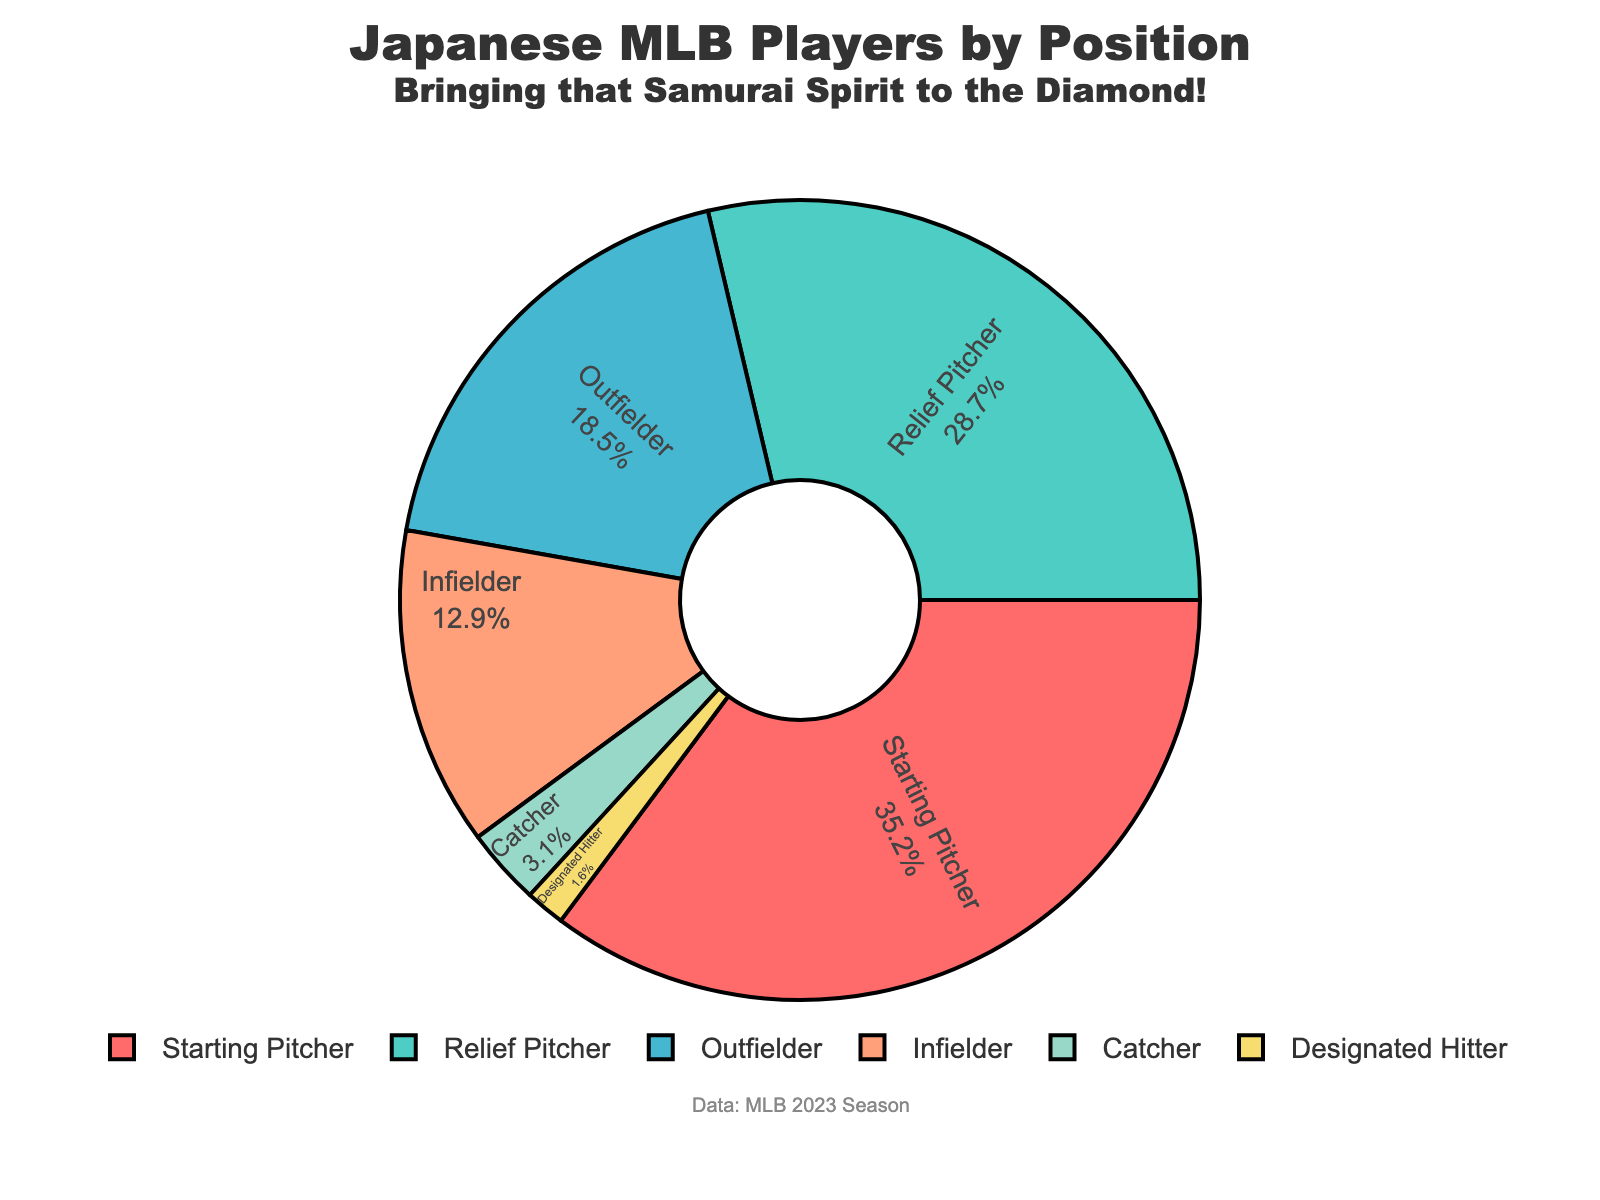Which position has the highest percentage of Japanese-born players in MLB? By observing the chart, we see that Starting Pitchers take up the largest segment.
Answer: Starting Pitcher What is the difference in percentage between Starting Pitchers and Relief Pitchers? Starting Pitchers have 35.2% and Relief Pitchers have 28.7%. The difference is 35.2 - 28.7 = 6.5%.
Answer: 6.5% Which position has the smallest percentage of Japanese-born players in MLB? By observing the smallest segment of the pie chart, we can see that Designated Hitter has the smallest percentage.
Answer: Designated Hitter How much more common are Japanese-born Outfielders compared to Catchers in MLB? Outfielders have 18.5% and Catchers have 3.1%. The difference is 18.5 - 3.1 = 15.4%.
Answer: 15.4% What is the total percentage of Japanese-born players from infield positions including Infielder, Catcher, and Designated Hitter? Sum the percentages of Infielder (12.9%), Catcher (3.1%), and Designated Hitter (1.6%), which gives 12.9 + 3.1 + 1.6 = 17.6%.
Answer: 17.6% Are there more Japanese-born Starting Pitchers or Outfielders in MLB? By comparing the percentages, we see Starting Pitchers have 35.2% and Outfielders have 18.5%. 35.2% > 18.5%.
Answer: Starting Pitchers Which color represents the Relief Pitchers in the pie chart? By looking at the visual attributes of the pie chart and the color pattern described, we see that Relief Pitchers are represented by the teal color.
Answer: teal If you combine the percentages of Japanese-born Outfielders and Infielders, do they make up more than 30% of the total? Sum the percentages of Outfielders (18.5%) and Infielders (12.9%), which gives 18.5 + 12.9 = 31.4%. Since 31.4% is more than 30%, the answer is yes.
Answer: yes Among the positions listed, which two positions together make up just over 60% of Japanese-born players in MLB? Combine Starting Pitchers (35.2%) and Relief Pitchers (28.7%); 35.2 + 28.7 = 63.9%. This is just over 60%.
Answer: Starting Pitcher and Relief Pitcher 